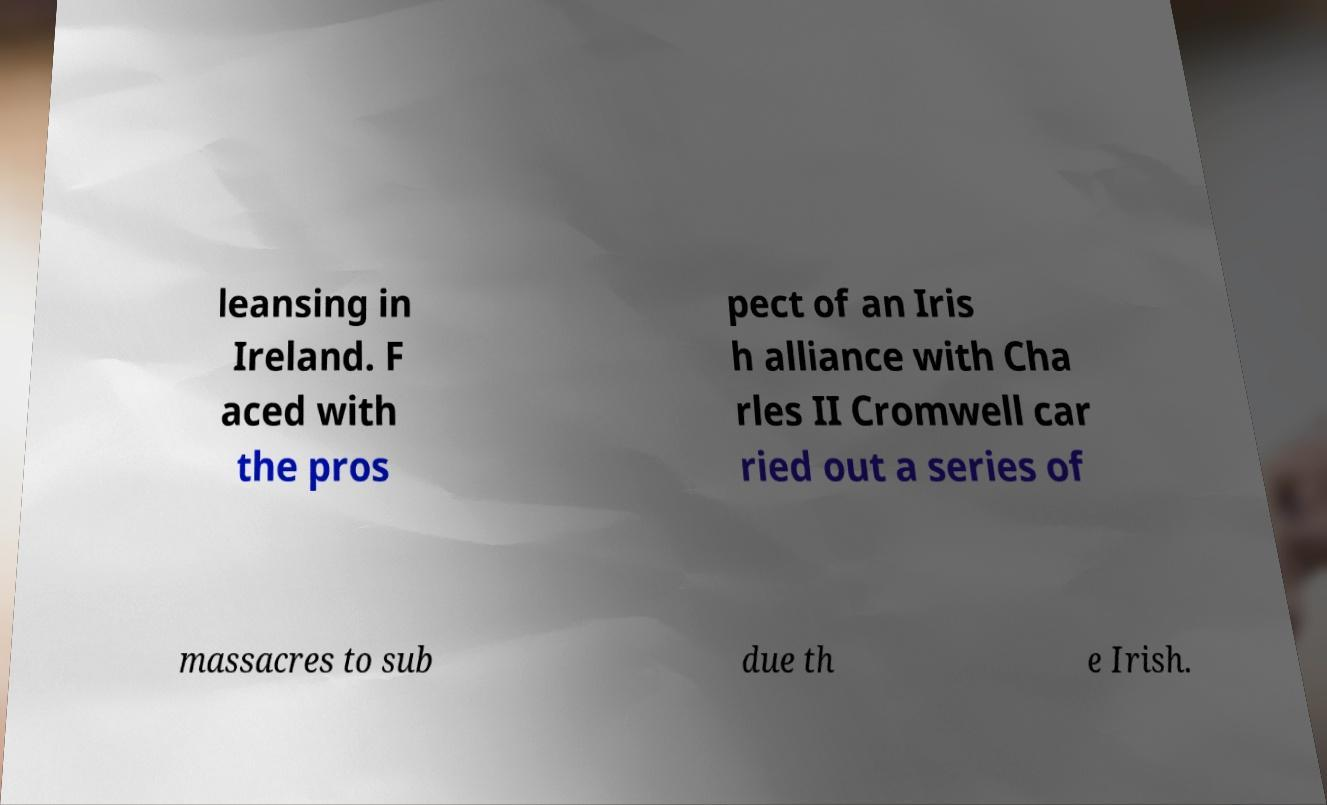Can you read and provide the text displayed in the image?This photo seems to have some interesting text. Can you extract and type it out for me? leansing in Ireland. F aced with the pros pect of an Iris h alliance with Cha rles II Cromwell car ried out a series of massacres to sub due th e Irish. 